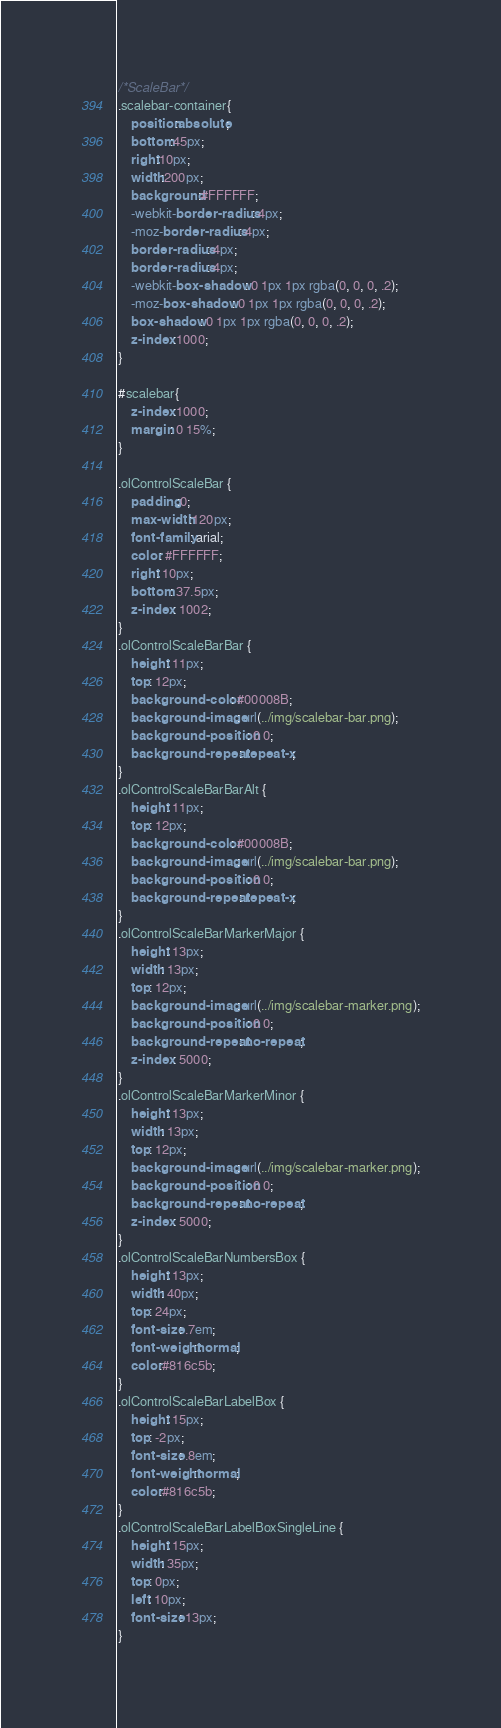<code> <loc_0><loc_0><loc_500><loc_500><_CSS_>/*ScaleBar*/
.scalebar-container{
    position:absolute;
    bottom:45px;
    right:10px;
    width:200px;
    background:#FFFFFF;
    -webkit-border-radius: 4px;  
    -moz-border-radius: 4px;  
    border-radius: 4px; 
    border-radius: 4px;
    -webkit-box-shadow: 0 1px 1px rgba(0, 0, 0, .2);
    -moz-box-shadow: 0 1px 1px rgba(0, 0, 0, .2);
    box-shadow: 0 1px 1px rgba(0, 0, 0, .2);
    z-index:1000;
}

#scalebar{
    z-index:1000;
    margin: 0 15%;
}

.olControlScaleBar {
    padding:0;
    max-width:120px;
    font-family: arial;
    color: #FFFFFF;
    right: 10px;
    bottom: 37.5px;
    z-index: 1002;
}
.olControlScaleBarBar {
    height: 11px;
    top: 12px;
    background-color: #00008B;
    background-image: url(../img/scalebar-bar.png);
    background-position: 0 0;
    background-repeat: repeat-x;
}
.olControlScaleBarBarAlt {
    height: 11px;
    top: 12px;
    background-color: #00008B;
    background-image: url(../img/scalebar-bar.png);
    background-position: 0 0;
    background-repeat: repeat-x;
}
.olControlScaleBarMarkerMajor {
    height: 13px;
    width: 13px;
    top: 12px;
    background-image: url(../img/scalebar-marker.png);
    background-position: 0 0;
    background-repeat: no-repeat;
    z-index: 5000;
}
.olControlScaleBarMarkerMinor {
    height: 13px;
    width: 13px;
    top: 12px;
    background-image: url(../img/scalebar-marker.png);
    background-position: 0 0;
    background-repeat: no-repeat;
    z-index: 5000;
}
.olControlScaleBarNumbersBox {
    height: 13px;
    width: 40px;
    top: 24px;
    font-size: .7em;
    font-weight:normal;
    color:#816c5b;
}
.olControlScaleBarLabelBox {
    height: 15px;
    top: -2px;
    font-size: .8em;
    font-weight:normal;
    color:#816c5b;
}
.olControlScaleBarLabelBoxSingleLine {
    height: 15px;
    width: 35px;
    top: 0px;
    left: 10px;
    font-size: 13px;
}
</code> 